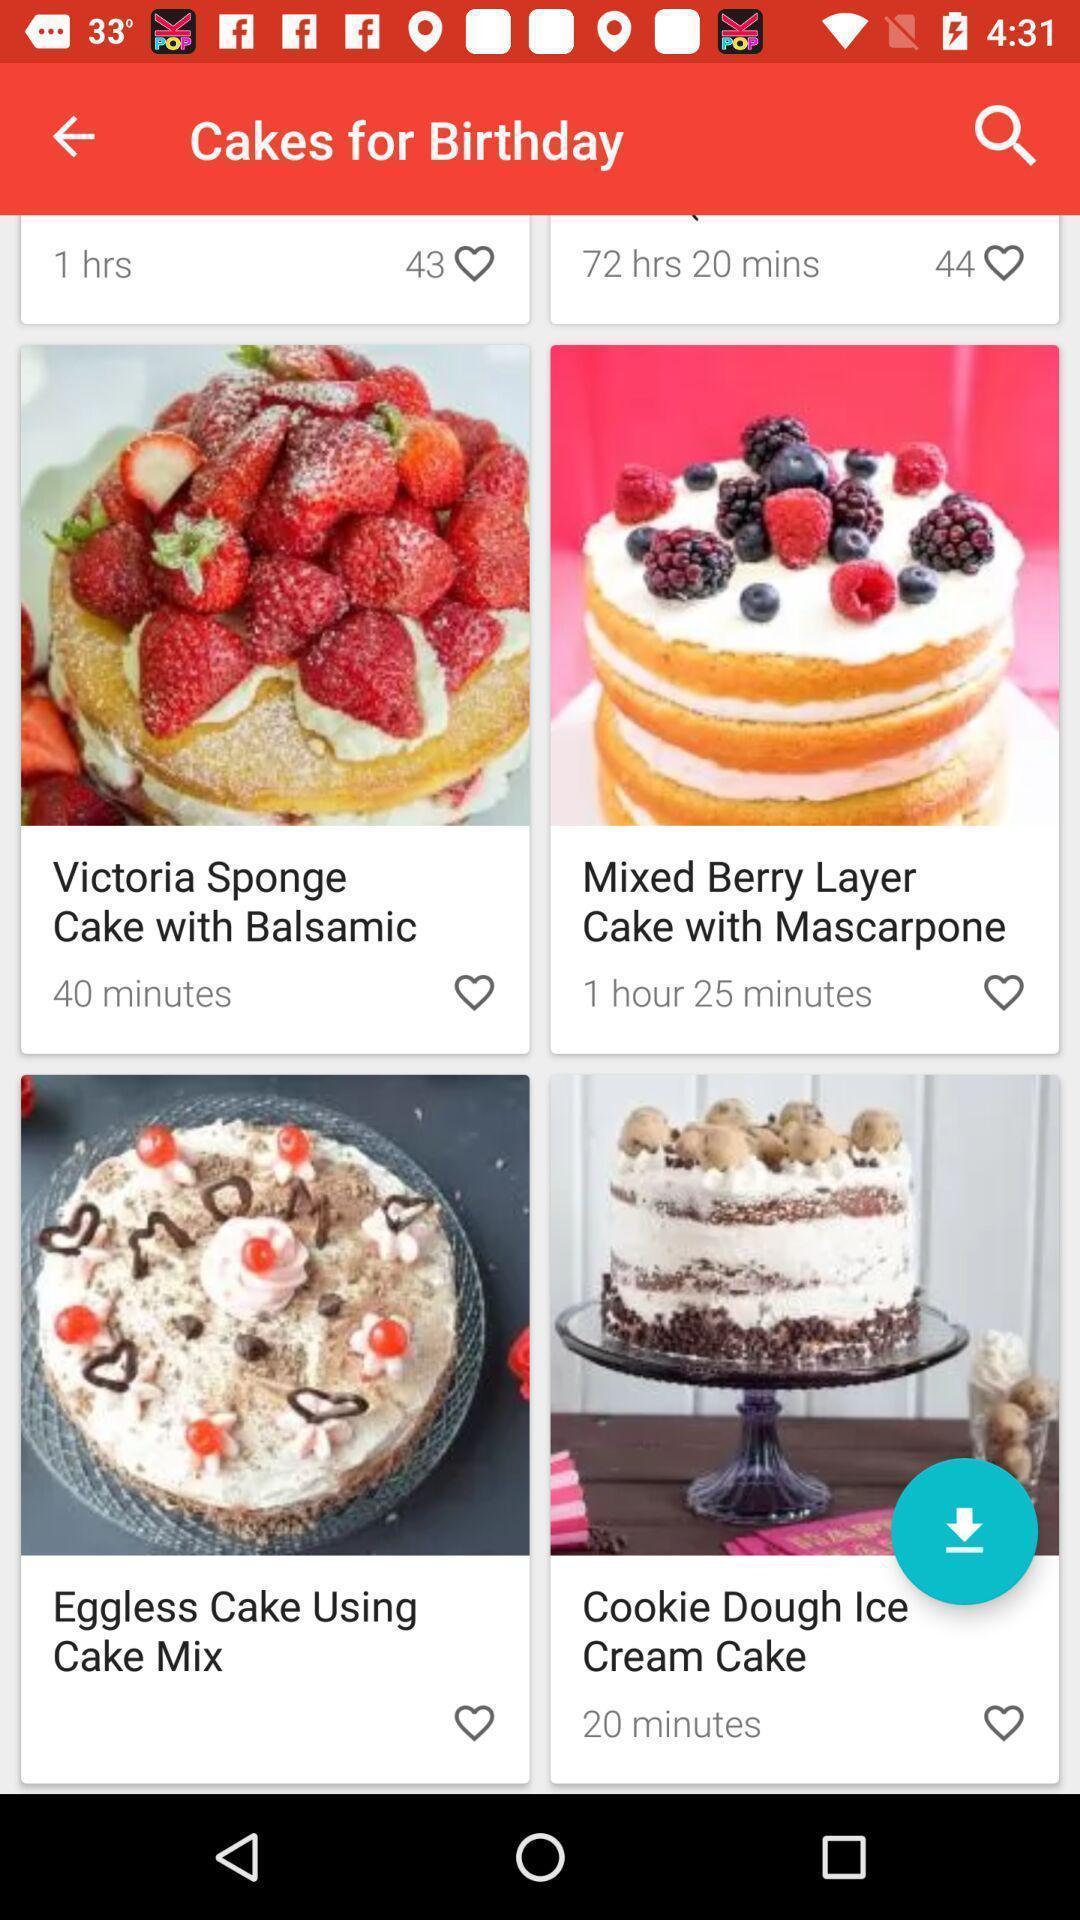Explain what's happening in this screen capture. Page showing list of various birthday cakes. 